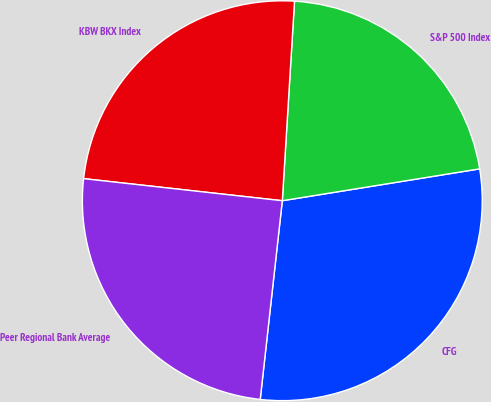<chart> <loc_0><loc_0><loc_500><loc_500><pie_chart><fcel>CFG<fcel>S&P 500 Index<fcel>KBW BKX Index<fcel>Peer Regional Bank Average<nl><fcel>29.31%<fcel>21.48%<fcel>24.21%<fcel>25.0%<nl></chart> 